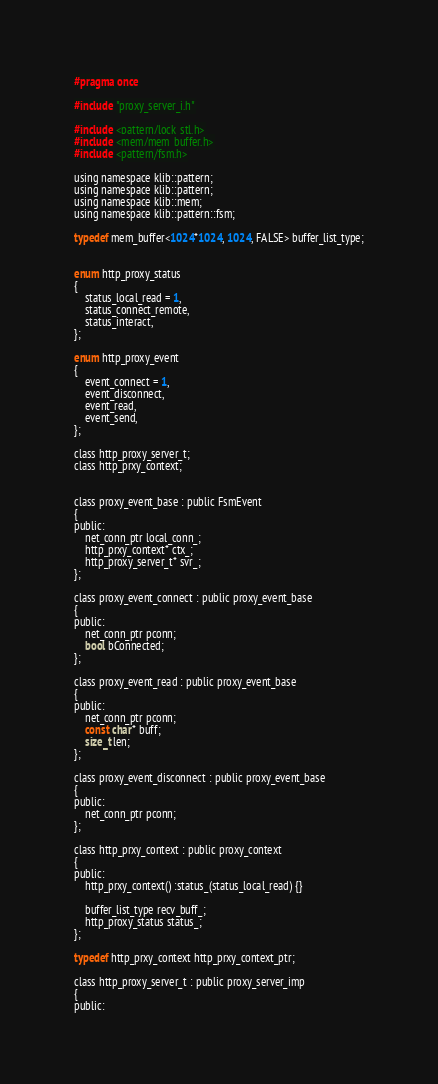<code> <loc_0><loc_0><loc_500><loc_500><_C_>#pragma once

#include "proxy_server_i.h"

#include <pattern/lock_stl.h>
#include <mem/mem_buffer.h>
#include <pattern/fsm.h>

using namespace klib::pattern;
using namespace klib::pattern;
using namespace klib::mem;
using namespace klib::pattern::fsm;

typedef mem_buffer<1024*1024, 1024, FALSE> buffer_list_type;


enum http_proxy_status
{
    status_local_read = 1,
    status_connect_remote,
    status_interact,
};

enum http_proxy_event
{
    event_connect = 1,
    event_disconnect,
    event_read,
    event_send,
};

class http_proxy_server_t;
class http_prxy_context;


class proxy_event_base : public FsmEvent
{
public:
    net_conn_ptr local_conn_;
    http_prxy_context* ctx_;
    http_proxy_server_t* svr_;
};

class proxy_event_connect : public proxy_event_base
{
public:
    net_conn_ptr pconn;
    bool bConnected;
};

class proxy_event_read : public proxy_event_base
{
public:
    net_conn_ptr pconn;
    const char* buff;
    size_t len;
};

class proxy_event_disconnect : public proxy_event_base
{
public:
    net_conn_ptr pconn;
};

class http_prxy_context : public proxy_context
{
public:
    http_prxy_context() :status_(status_local_read) {}

    buffer_list_type recv_buff_;
    http_proxy_status status_;
};

typedef http_prxy_context http_prxy_context_ptr;

class http_proxy_server_t : public proxy_server_imp
{
public:</code> 